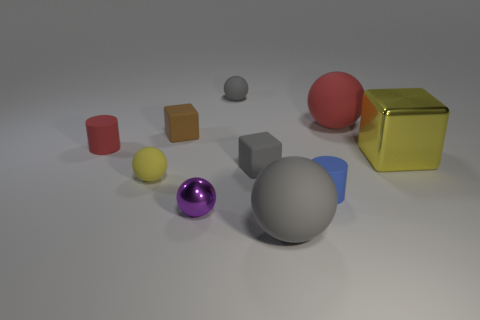Subtract all tiny balls. How many balls are left? 2 Subtract all yellow blocks. How many gray balls are left? 2 Subtract all yellow spheres. How many spheres are left? 4 Subtract 2 spheres. How many spheres are left? 3 Subtract all cylinders. How many objects are left? 8 Subtract all green blocks. Subtract all blue cylinders. How many blocks are left? 3 Subtract all tiny blue cubes. Subtract all matte blocks. How many objects are left? 8 Add 3 gray objects. How many gray objects are left? 6 Add 9 tiny red objects. How many tiny red objects exist? 10 Subtract 0 red blocks. How many objects are left? 10 